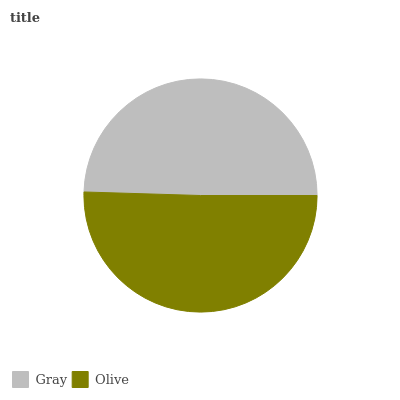Is Gray the minimum?
Answer yes or no. Yes. Is Olive the maximum?
Answer yes or no. Yes. Is Olive the minimum?
Answer yes or no. No. Is Olive greater than Gray?
Answer yes or no. Yes. Is Gray less than Olive?
Answer yes or no. Yes. Is Gray greater than Olive?
Answer yes or no. No. Is Olive less than Gray?
Answer yes or no. No. Is Olive the high median?
Answer yes or no. Yes. Is Gray the low median?
Answer yes or no. Yes. Is Gray the high median?
Answer yes or no. No. Is Olive the low median?
Answer yes or no. No. 